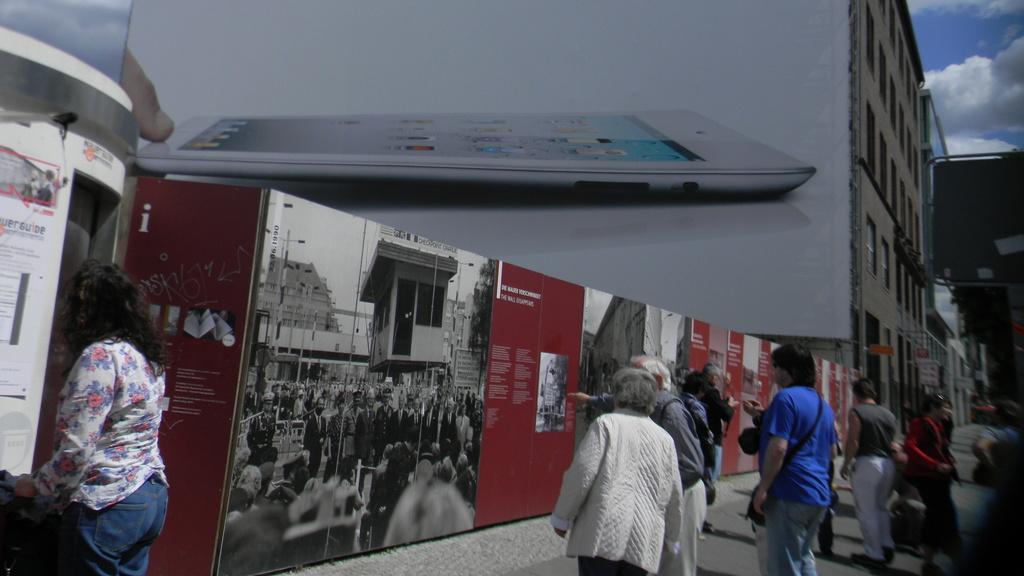In one or two sentences, can you explain what this image depicts? In the image there is a building and there is a big poster to the wall of the building, under that there is a wall and there are different posters with people images and texts. In front of those posters there are few people. 